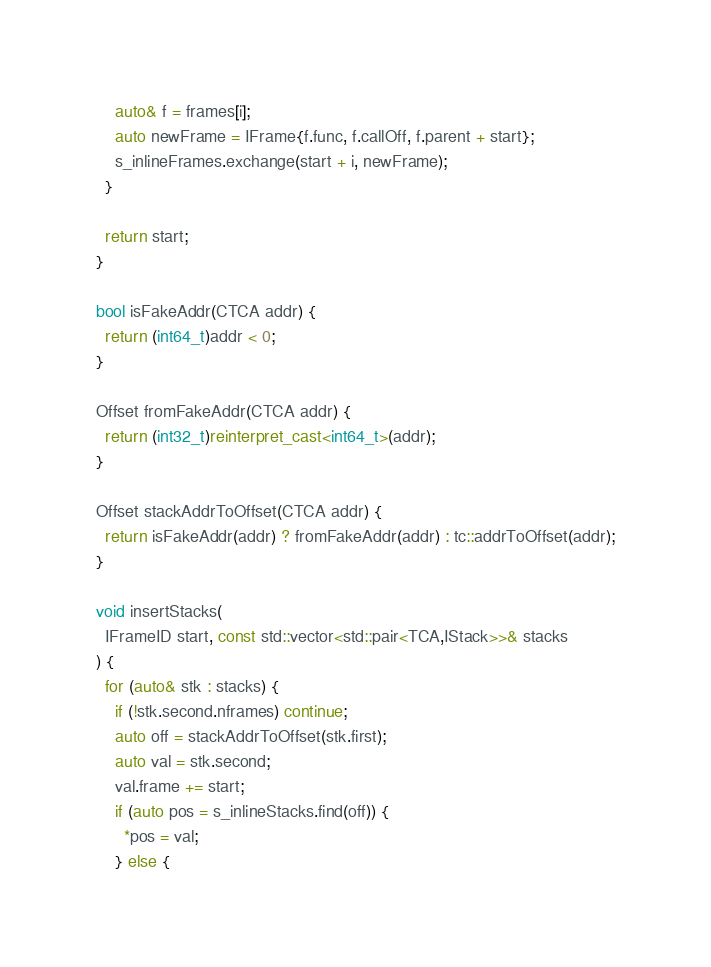Convert code to text. <code><loc_0><loc_0><loc_500><loc_500><_C++_>    auto& f = frames[i];
    auto newFrame = IFrame{f.func, f.callOff, f.parent + start};
    s_inlineFrames.exchange(start + i, newFrame);
  }

  return start;
}

bool isFakeAddr(CTCA addr) {
  return (int64_t)addr < 0;
}

Offset fromFakeAddr(CTCA addr) {
  return (int32_t)reinterpret_cast<int64_t>(addr);
}

Offset stackAddrToOffset(CTCA addr) {
  return isFakeAddr(addr) ? fromFakeAddr(addr) : tc::addrToOffset(addr);
}

void insertStacks(
  IFrameID start, const std::vector<std::pair<TCA,IStack>>& stacks
) {
  for (auto& stk : stacks) {
    if (!stk.second.nframes) continue;
    auto off = stackAddrToOffset(stk.first);
    auto val = stk.second;
    val.frame += start;
    if (auto pos = s_inlineStacks.find(off)) {
      *pos = val;
    } else {</code> 